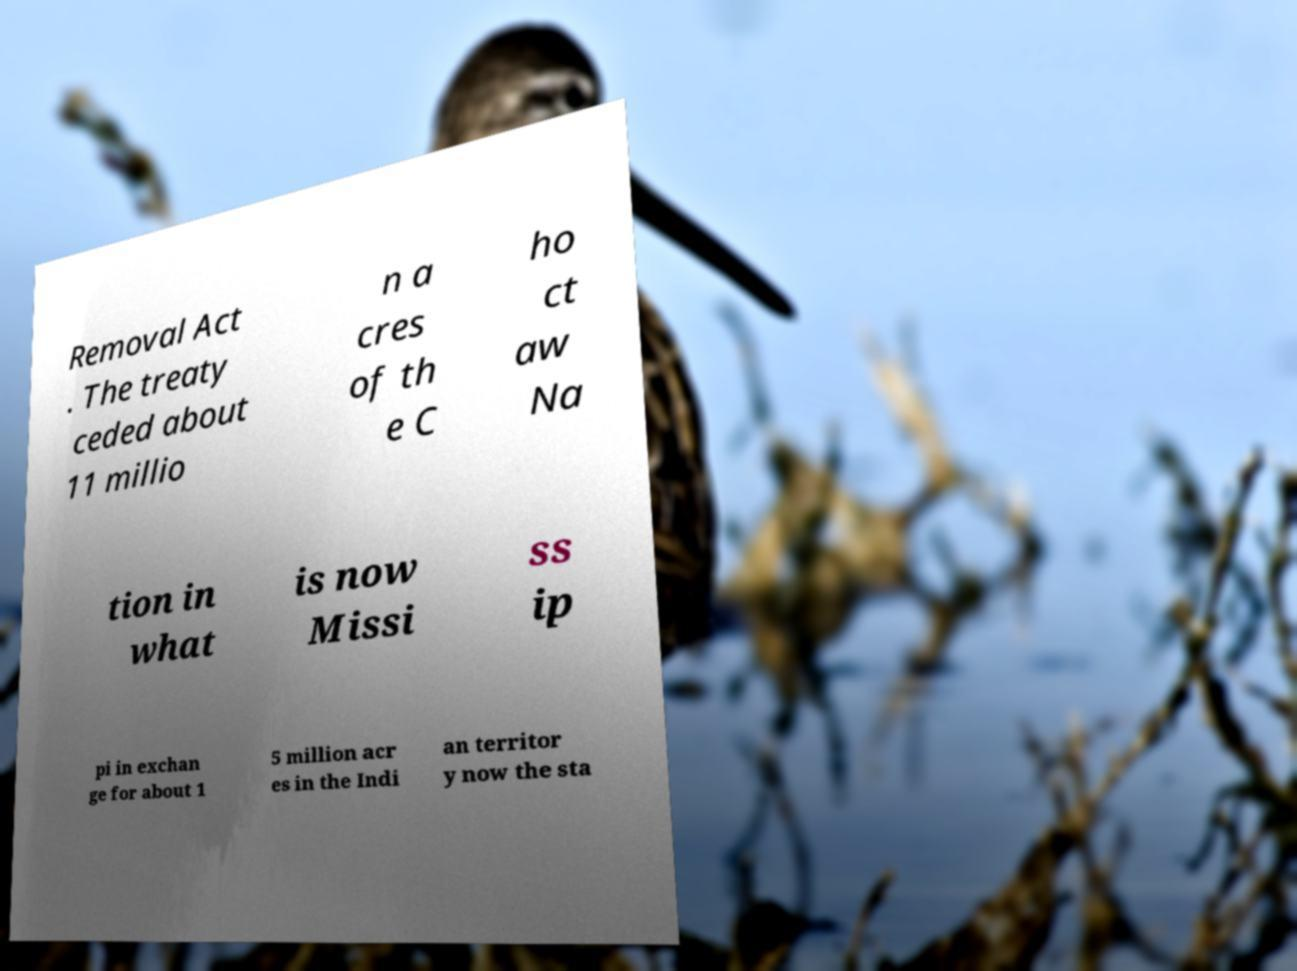What messages or text are displayed in this image? I need them in a readable, typed format. Removal Act . The treaty ceded about 11 millio n a cres of th e C ho ct aw Na tion in what is now Missi ss ip pi in exchan ge for about 1 5 million acr es in the Indi an territor y now the sta 